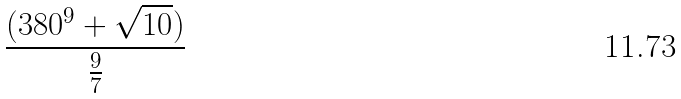<formula> <loc_0><loc_0><loc_500><loc_500>\frac { ( 3 8 0 ^ { 9 } + \sqrt { 1 0 } ) } { \frac { 9 } { 7 } }</formula> 